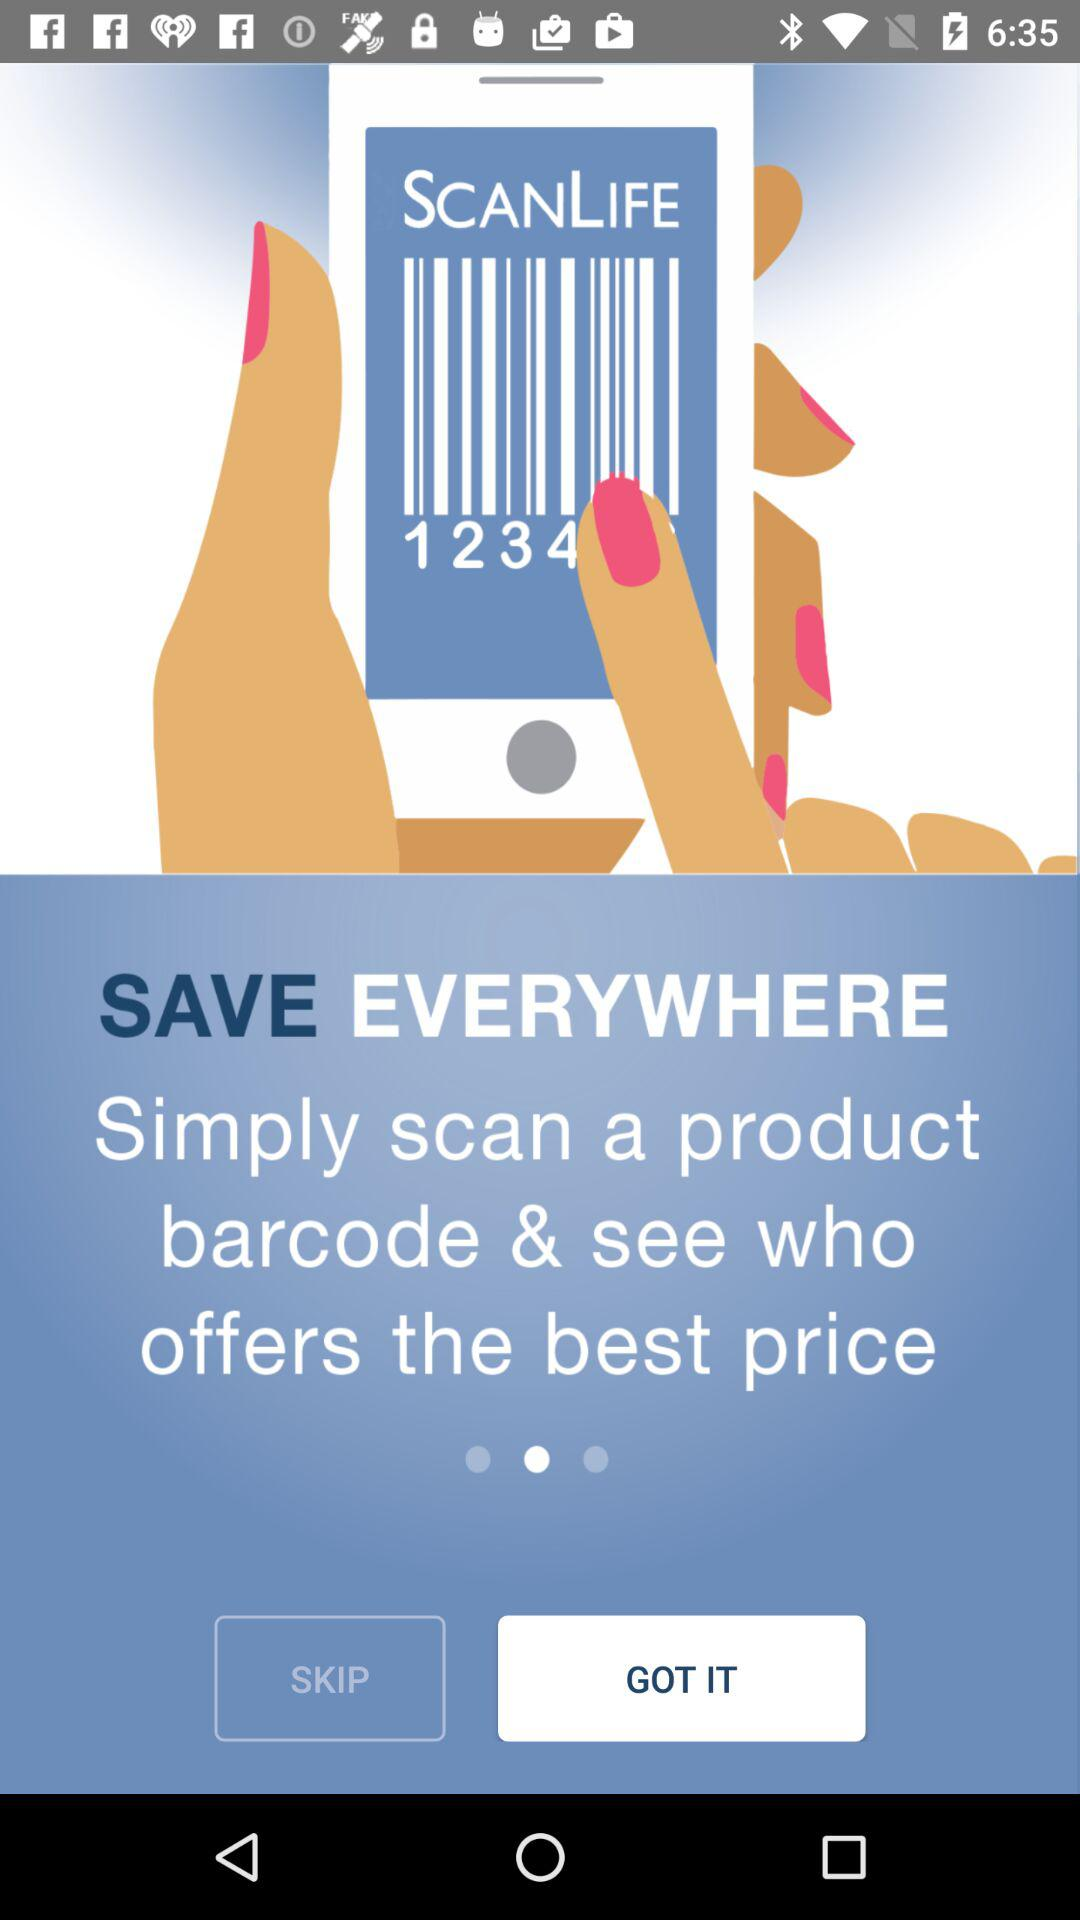What is the name of the application? The name of the application is "SCANLIFE". 